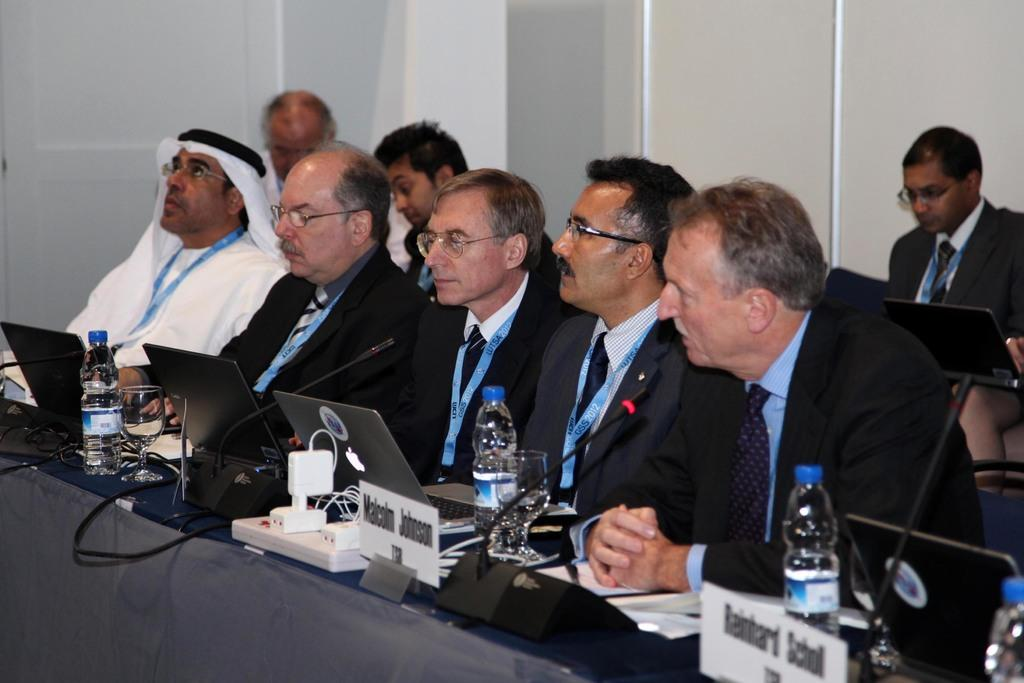What are the persons in the image doing? The persons in the image are sitting on chairs. What electronic devices can be seen in the image? There are laptops in the image. What equipment is used for amplifying sound in the image? There are microphones (mikes) in the image. What type of containers are present in the image? There are bottles in the image. What objects are used for identification in the image? There are name boards in the image. What type of tableware is visible in the image? There are glasses in the image. What can be seen in the background of the image? There is a wall in the background of the image. What type of soup is being served in the image? There is no soup present in the image. How many boys are visible in the image? The image does not specify the gender of the persons, so it is not possible to determine the number of boys. 